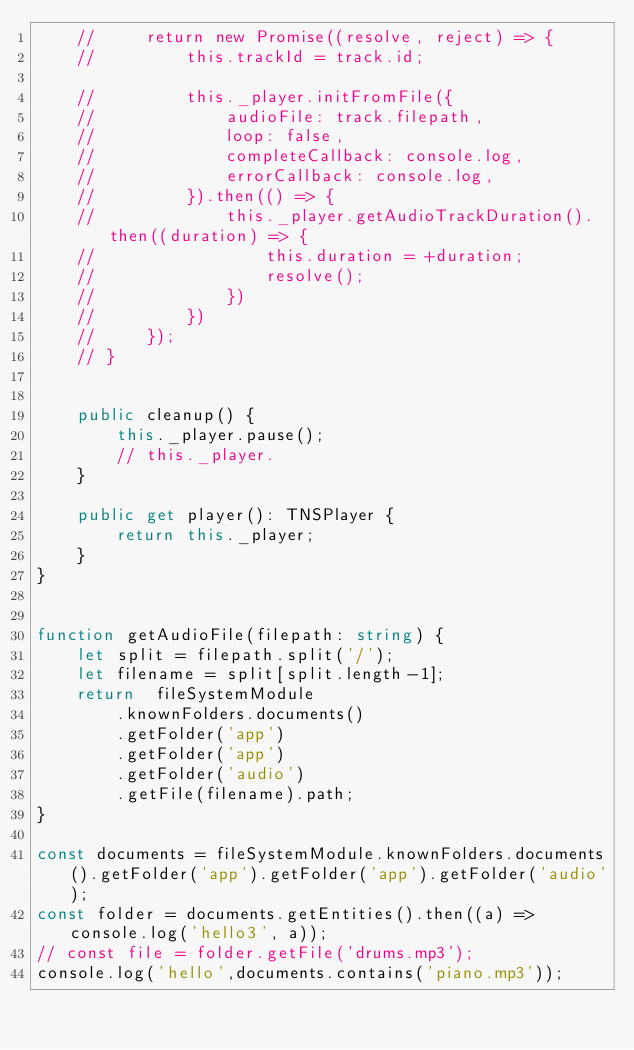<code> <loc_0><loc_0><loc_500><loc_500><_TypeScript_>    //     return new Promise((resolve, reject) => {
    //         this.trackId = track.id;

    //         this._player.initFromFile({
    //             audioFile: track.filepath,
    //             loop: false,
    //             completeCallback: console.log,
    //             errorCallback: console.log,
    //         }).then(() => {
    //             this._player.getAudioTrackDuration().then((duration) => {
    //                 this.duration = +duration;
    //                 resolve();
    //             })
    //         })
    //     });
    // }


    public cleanup() {
        this._player.pause();
        // this._player.
    }

    public get player(): TNSPlayer {
        return this._player;
    }
}


function getAudioFile(filepath: string) {
    let split = filepath.split('/');
    let filename = split[split.length-1];
    return  fileSystemModule
        .knownFolders.documents()
        .getFolder('app')
        .getFolder('app')
        .getFolder('audio')
        .getFile(filename).path;
}

const documents = fileSystemModule.knownFolders.documents().getFolder('app').getFolder('app').getFolder('audio');
const folder = documents.getEntities().then((a) => console.log('hello3', a));
// const file = folder.getFile('drums.mp3');
console.log('hello',documents.contains('piano.mp3'));
</code> 